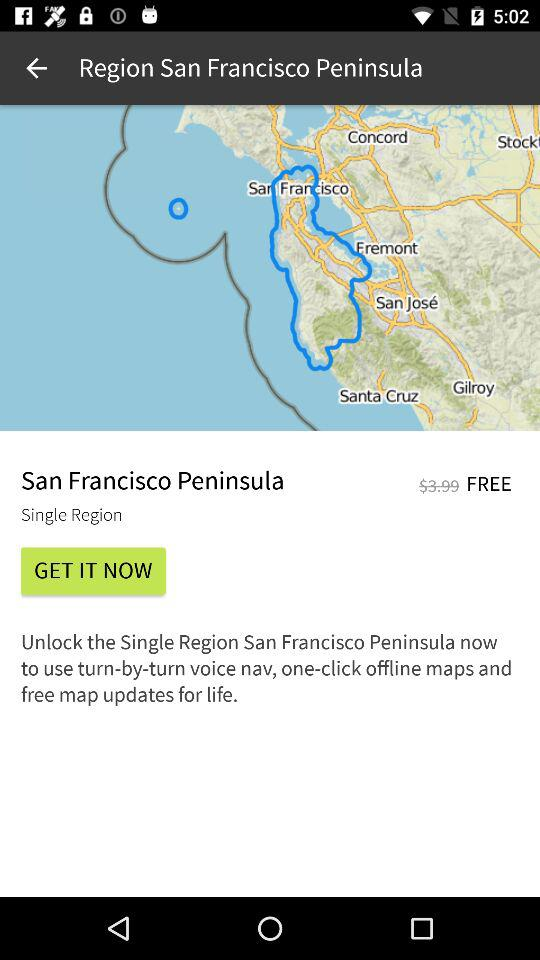What is the region name? The region name is San Francisco Peninsula. 